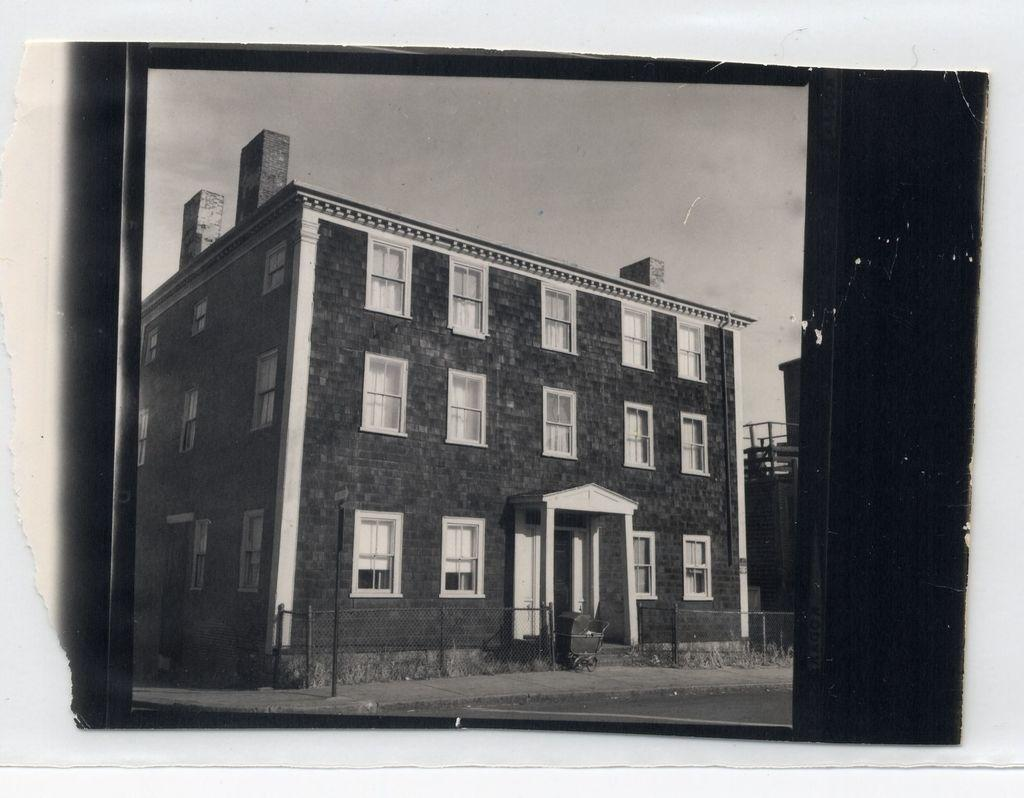What is the color scheme of the image? The image is black and white. What is the main subject of the image? There is a photograph of a building in the image. What architectural feature is prominent on the building? The building has many windows. What type of rock is visible in the image? There is no rock present in the image; it features a photograph of a building with many windows. 